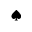Convert formula to latex. <formula><loc_0><loc_0><loc_500><loc_500>^ { a } d e s u i t</formula> 